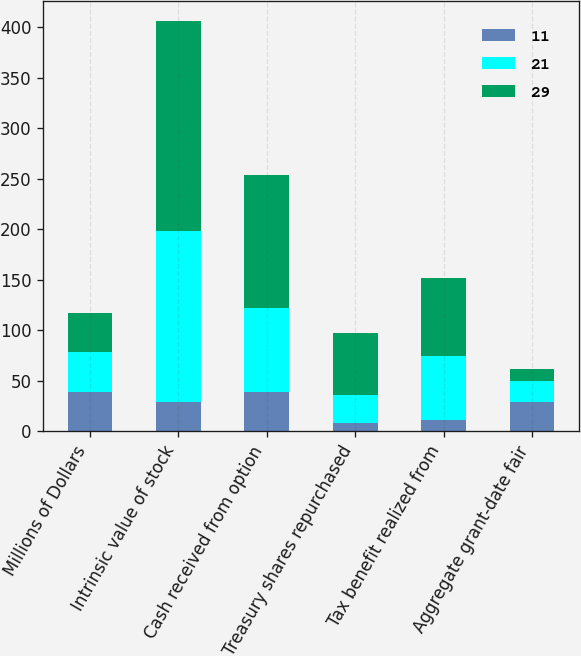<chart> <loc_0><loc_0><loc_500><loc_500><stacked_bar_chart><ecel><fcel>Millions of Dollars<fcel>Intrinsic value of stock<fcel>Cash received from option<fcel>Treasury shares repurchased<fcel>Tax benefit realized from<fcel>Aggregate grant-date fair<nl><fcel>11<fcel>39<fcel>29<fcel>39<fcel>8<fcel>11<fcel>29<nl><fcel>21<fcel>39<fcel>169<fcel>83<fcel>28<fcel>63<fcel>21<nl><fcel>29<fcel>39<fcel>208<fcel>132<fcel>61<fcel>78<fcel>11<nl></chart> 